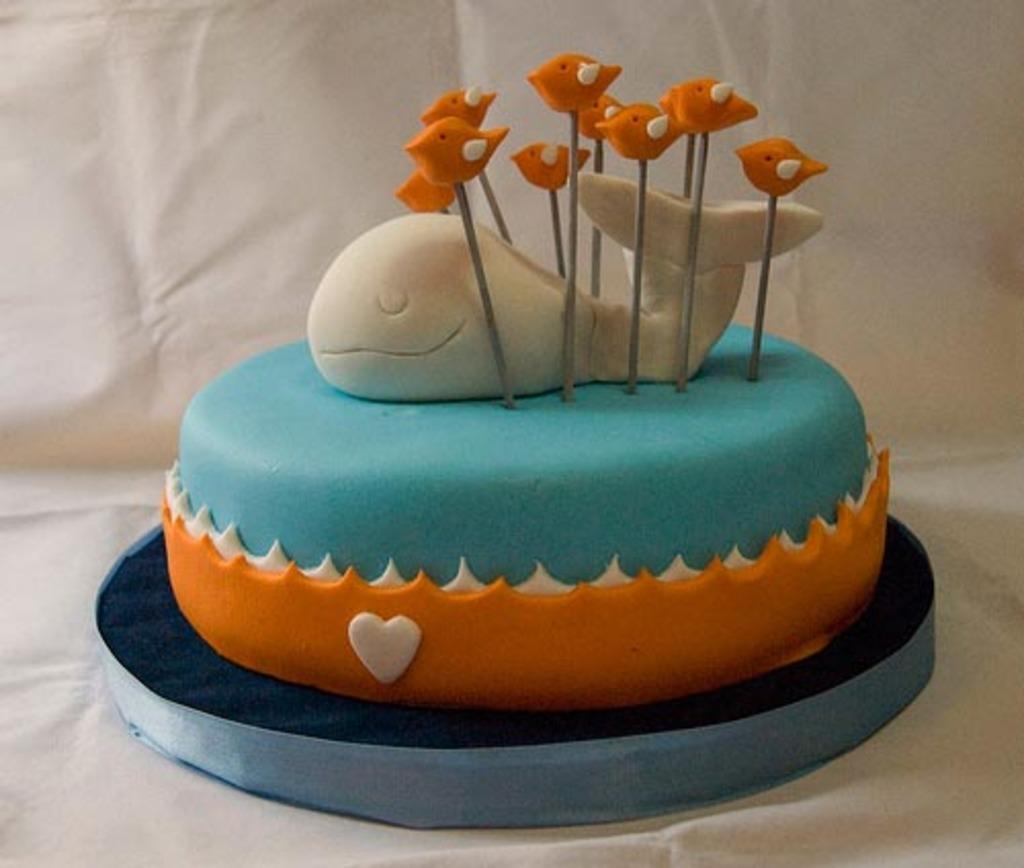In one or two sentences, can you explain what this image depicts? In the picture I can see a designer cake which is in orange, blue and white color. It is placed on the white color surface. Here I can see the cake on which I can see the shapes of a fish and birds. 